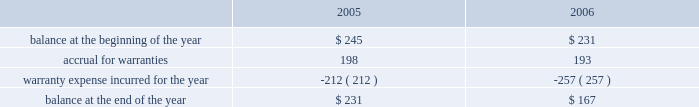Abiomed , inc .
And subsidiaries notes to consolidated financial statements 2014 ( continued ) evidence of an arrangement exists , ( 2 ) delivery has occurred or services have been rendered , ( 3 ) the seller 2019s price to the buyer is fixed or determinable , and ( 4 ) collectibility is reasonably assured .
Further , sab 104 requires that both title and the risks and rewards of ownership be transferred to the buyer before revenue can be recognized .
In addition to sab 104 , we follow the guidance of eitf 00-21 , revenue arrangements with multiple deliverables .
We derive our revenues primarily from product sales , including maintenance service agreements .
The great majority of our product revenues are derived from shipments of our ab5000 and bvs 5000 product lines to fulfill customer orders for a specified number of consoles and/or blood pumps for a specified price .
We recognize revenues and record costs related to such sales upon product shipment .
Maintenance and service support contract revenues are recognized ratably over the term of the service contracts based upon the elapsed term of the service contract .
Government-sponsored research and development contracts and grants generally provide for payment on a cost-plus-fixed-fee basis .
Revenues from these contracts and grants are recognized as work is performed , provided the government has appropriated sufficient funds for the work .
Under contracts in which the company elects to spend significantly more on the development project during the term of the contract than the total contract amount , the company prospectively recognizes revenue on such contracts ratably over the term of the contract as it incurs related research and development costs , provided the government has appropriated sufficient funds for the work .
( d ) translation of foreign currencies all assets and liabilities of the company 2019s non-u.s .
Subsidiaries are translated at year-end exchange rates , and revenues and expenses are translated at average exchange rates for the year in accordance with sfas no .
52 , foreign currency translation .
Resulting translation adjustments are reflected in the accumulated other comprehensive loss component of shareholders 2019 equity .
Currency transaction gains and losses are included in the accompanying statement of income and are not material for the three years presented .
( e ) warranties the company routinely accrues for estimated future warranty costs on its product sales at the time of sale .
Our products are subject to rigorous regulation and quality standards .
Warranty costs are included in cost of product revenues within the consolidated statements of operations .
The table summarizes the activities in the warranty reserve for the two fiscal years ended march 31 , 2006 ( in thousands ) .

What was the percentage change in warranty reserve from 2005 to 2006? 
Computations: ((167 - 231) / 231)
Answer: -0.27706. 